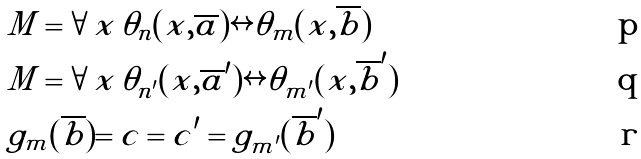Convert formula to latex. <formula><loc_0><loc_0><loc_500><loc_500>& M \models \forall \, x \, \theta _ { n } ( x , \overline { a } ) \leftrightarrow \theta _ { m } ( x , \overline { b } ) \\ & M \models \forall \, x \, \theta _ { n ^ { \prime } } ( x , \overline { a } ^ { \prime } ) \leftrightarrow \theta _ { m ^ { \prime } } ( x , \overline { b } ^ { \prime } ) \\ & g _ { m } ( \overline { b } ) = c = c ^ { \prime } = g _ { m ^ { \prime } } ( \overline { b } ^ { \prime } )</formula> 